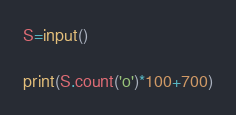Convert code to text. <code><loc_0><loc_0><loc_500><loc_500><_Python_>S=input()

print(S.count('o')*100+700)</code> 